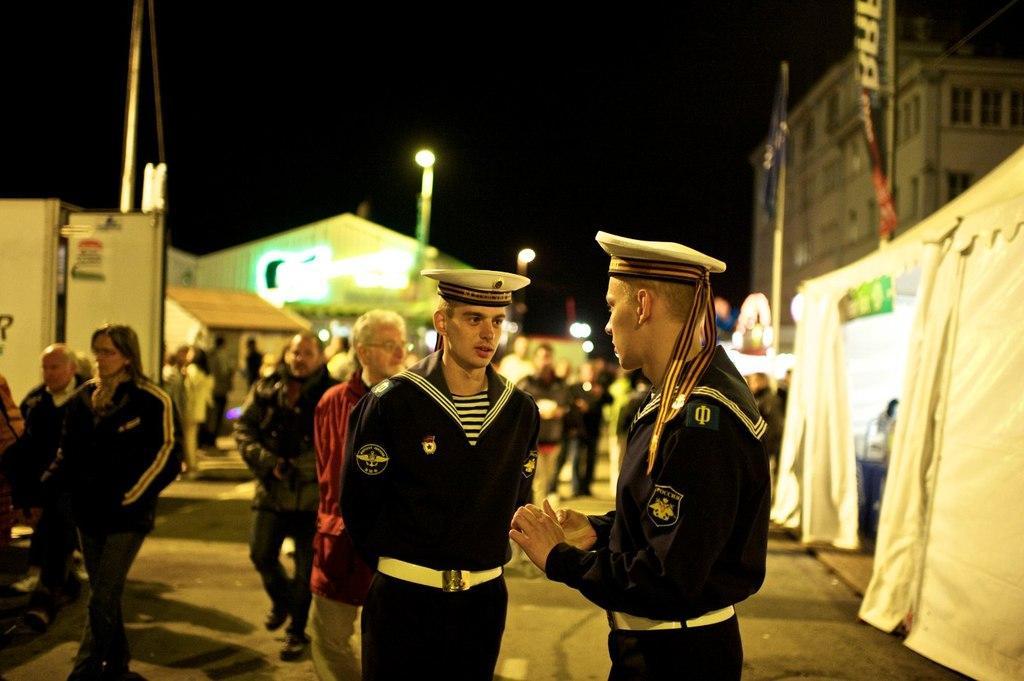Could you give a brief overview of what you see in this image? In this image we can see many people. There is a building at the right side of the image. There are few advertising flags in the image. There are few tents in the image. There are few lights in the image. There is a vehicle at the left side of the image. 